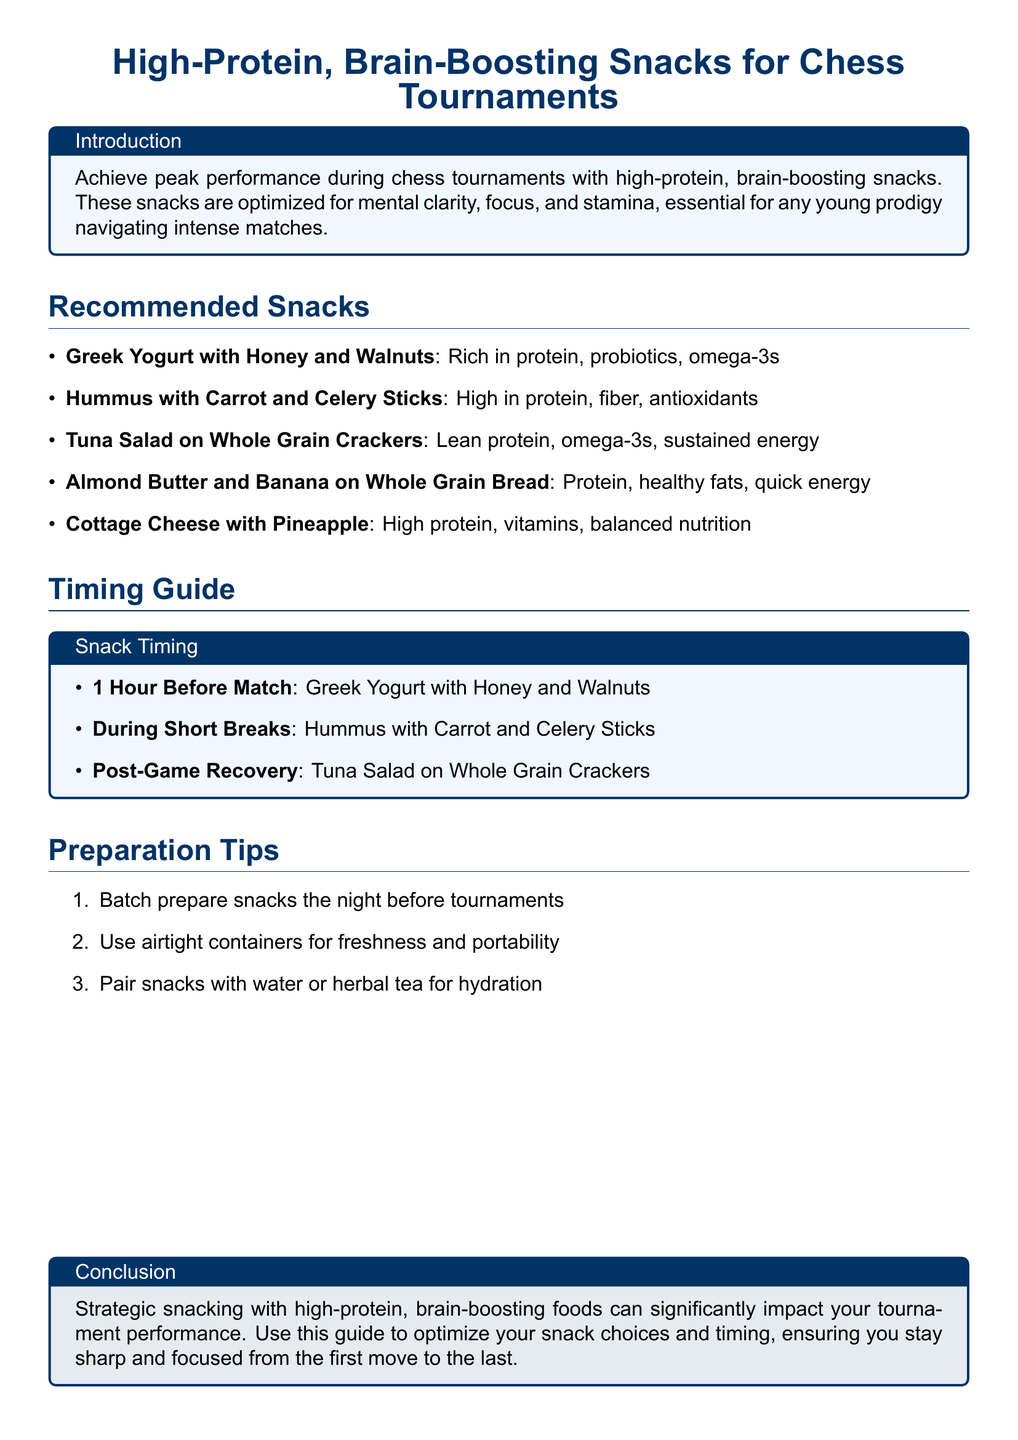What is the first snack listed? The first snack listed in the document is "Greek Yogurt with Honey and Walnuts."
Answer: Greek Yogurt with Honey and Walnuts How much time before a match should you eat Greek Yogurt? The document states that Greek Yogurt should be consumed 1 hour before the match.
Answer: 1 Hour Which snack is recommended during short breaks? The document mentions "Hummus with Carrot and Celery Sticks" for consumption during short breaks.
Answer: Hummus with Carrot and Celery Sticks What are the benefits of Tuna Salad? According to the document, Tuna Salad is lean protein and provides omega-3s and sustained energy.
Answer: Lean protein, omega-3s, sustained energy What should be paired with snacks for hydration? The document recommends pairing snacks with water or herbal tea for hydration.
Answer: Water or herbal tea How should snacks be prepared for tournaments? The document advises to batch prepare snacks the night before tournaments.
Answer: Batch prepare snacks What color is the main text used in the title? The main color used in the title is described in the document as RGB(0,51,102).
Answer: RGB(0,51,102) What type of foods does the conclusion highlight? The conclusion emphasizes strategic snacking with high-protein and brain-boosting foods.
Answer: High-protein, brain-boosting foods 